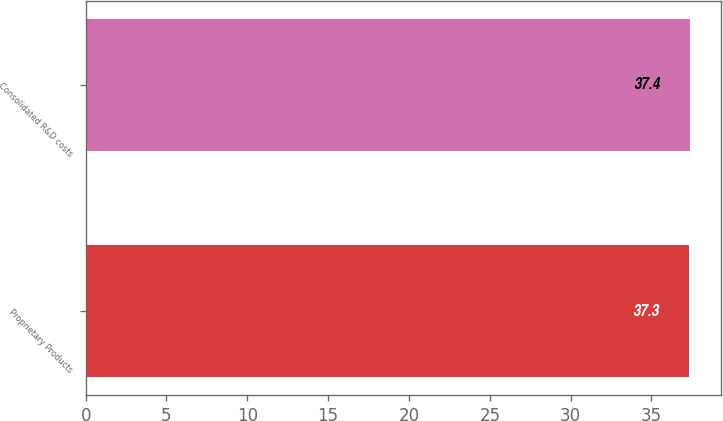<chart> <loc_0><loc_0><loc_500><loc_500><bar_chart><fcel>Proprietary Products<fcel>Consolidated R&D costs<nl><fcel>37.3<fcel>37.4<nl></chart> 